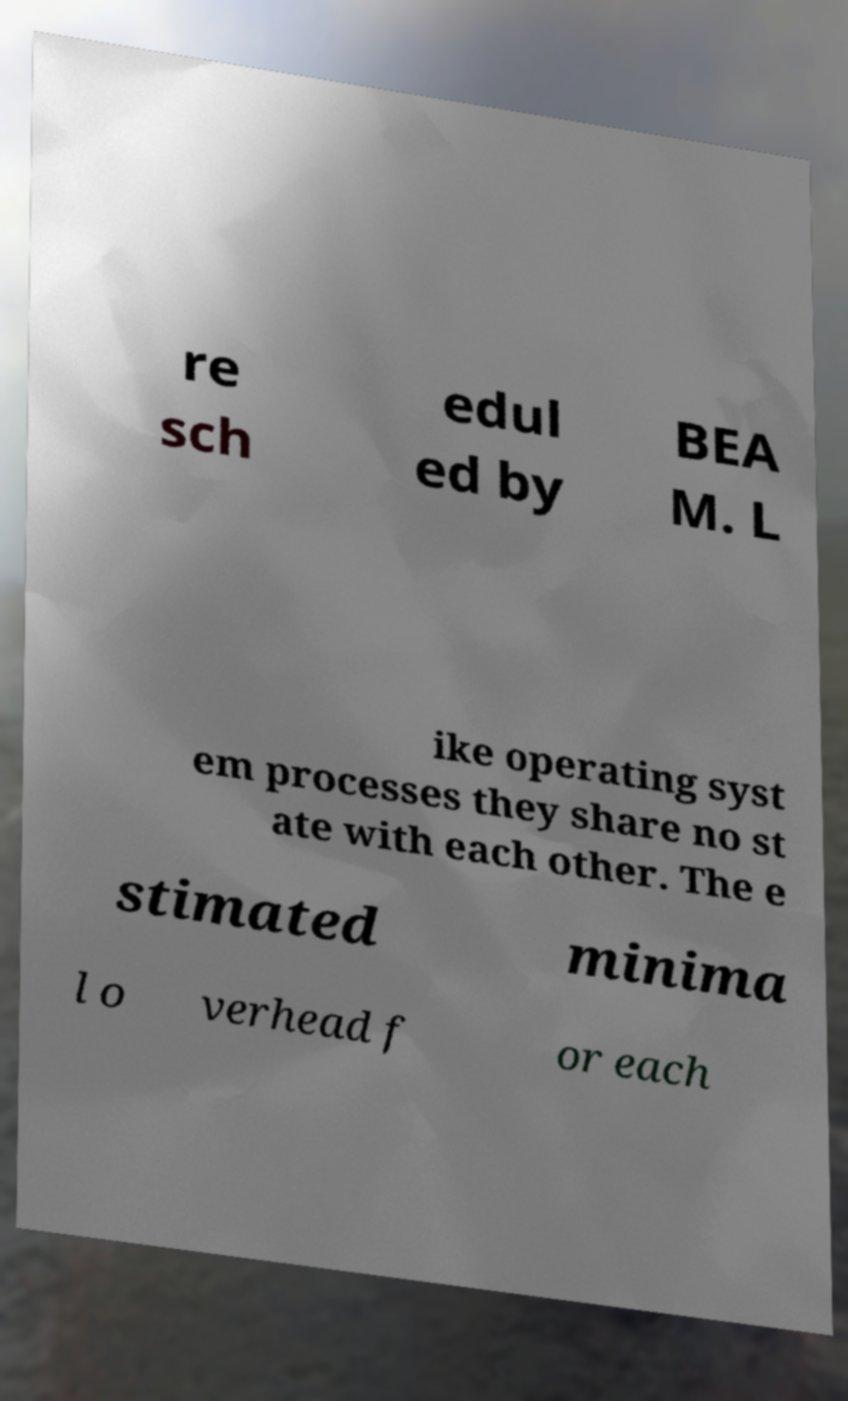Could you assist in decoding the text presented in this image and type it out clearly? re sch edul ed by BEA M. L ike operating syst em processes they share no st ate with each other. The e stimated minima l o verhead f or each 